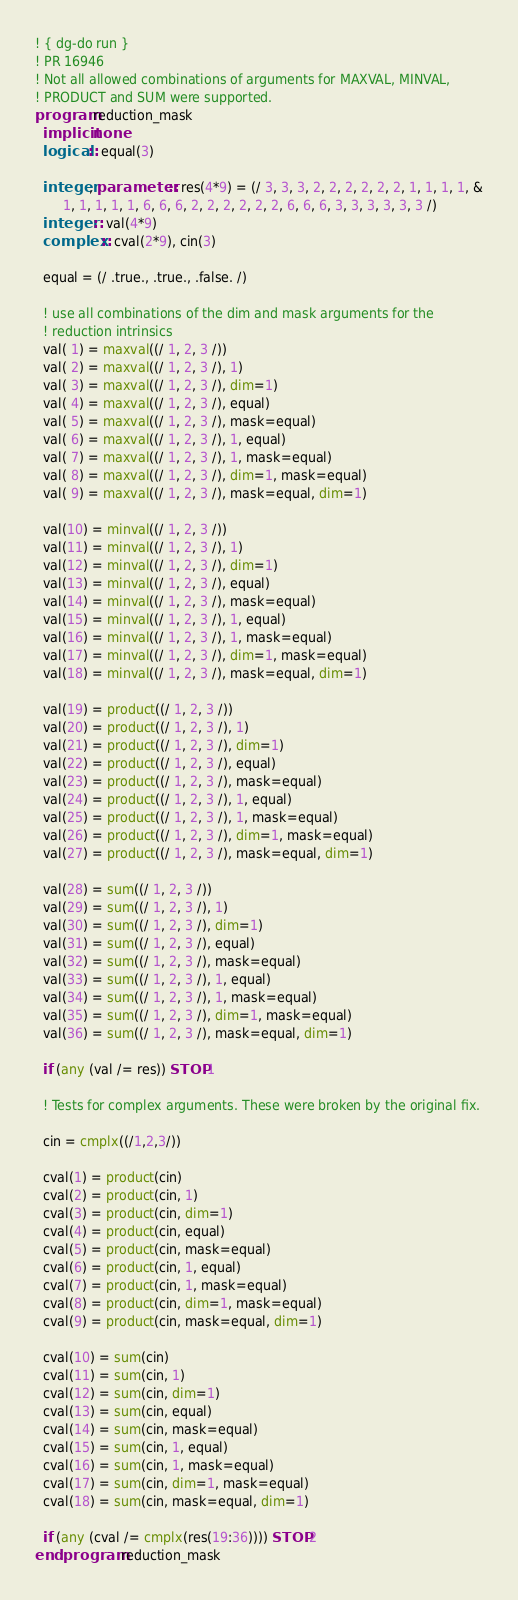<code> <loc_0><loc_0><loc_500><loc_500><_FORTRAN_>! { dg-do run }
! PR 16946
! Not all allowed combinations of arguments for MAXVAL, MINVAL,
! PRODUCT and SUM were supported.
program reduction_mask
  implicit none
  logical :: equal(3)
  
  integer, parameter :: res(4*9) = (/ 3, 3, 3, 2, 2, 2, 2, 2, 2, 1, 1, 1, 1, &
       1, 1, 1, 1, 1, 6, 6, 6, 2, 2, 2, 2, 2, 2, 6, 6, 6, 3, 3, 3, 3, 3, 3 /)
  integer :: val(4*9)
  complex :: cval(2*9), cin(3)
  
  equal = (/ .true., .true., .false. /)
  
  ! use all combinations of the dim and mask arguments for the
  ! reduction intrinsics
  val( 1) = maxval((/ 1, 2, 3 /))
  val( 2) = maxval((/ 1, 2, 3 /), 1)
  val( 3) = maxval((/ 1, 2, 3 /), dim=1)
  val( 4) = maxval((/ 1, 2, 3 /), equal)
  val( 5) = maxval((/ 1, 2, 3 /), mask=equal)
  val( 6) = maxval((/ 1, 2, 3 /), 1, equal)
  val( 7) = maxval((/ 1, 2, 3 /), 1, mask=equal)
  val( 8) = maxval((/ 1, 2, 3 /), dim=1, mask=equal)
  val( 9) = maxval((/ 1, 2, 3 /), mask=equal, dim=1)
       
  val(10) = minval((/ 1, 2, 3 /))
  val(11) = minval((/ 1, 2, 3 /), 1)
  val(12) = minval((/ 1, 2, 3 /), dim=1)
  val(13) = minval((/ 1, 2, 3 /), equal)
  val(14) = minval((/ 1, 2, 3 /), mask=equal)
  val(15) = minval((/ 1, 2, 3 /), 1, equal)
  val(16) = minval((/ 1, 2, 3 /), 1, mask=equal)
  val(17) = minval((/ 1, 2, 3 /), dim=1, mask=equal)
  val(18) = minval((/ 1, 2, 3 /), mask=equal, dim=1)
       
  val(19) = product((/ 1, 2, 3 /))
  val(20) = product((/ 1, 2, 3 /), 1)
  val(21) = product((/ 1, 2, 3 /), dim=1)
  val(22) = product((/ 1, 2, 3 /), equal)
  val(23) = product((/ 1, 2, 3 /), mask=equal)
  val(24) = product((/ 1, 2, 3 /), 1, equal)
  val(25) = product((/ 1, 2, 3 /), 1, mask=equal)
  val(26) = product((/ 1, 2, 3 /), dim=1, mask=equal)
  val(27) = product((/ 1, 2, 3 /), mask=equal, dim=1)
       
  val(28) = sum((/ 1, 2, 3 /))
  val(29) = sum((/ 1, 2, 3 /), 1)
  val(30) = sum((/ 1, 2, 3 /), dim=1)
  val(31) = sum((/ 1, 2, 3 /), equal)
  val(32) = sum((/ 1, 2, 3 /), mask=equal)
  val(33) = sum((/ 1, 2, 3 /), 1, equal)
  val(34) = sum((/ 1, 2, 3 /), 1, mask=equal)
  val(35) = sum((/ 1, 2, 3 /), dim=1, mask=equal)
  val(36) = sum((/ 1, 2, 3 /), mask=equal, dim=1)
  
  if (any (val /= res)) STOP 1

  ! Tests for complex arguments. These were broken by the original fix.

  cin = cmplx((/1,2,3/))

  cval(1) = product(cin)
  cval(2) = product(cin, 1)
  cval(3) = product(cin, dim=1)
  cval(4) = product(cin, equal)
  cval(5) = product(cin, mask=equal)
  cval(6) = product(cin, 1, equal)
  cval(7) = product(cin, 1, mask=equal)
  cval(8) = product(cin, dim=1, mask=equal)
  cval(9) = product(cin, mask=equal, dim=1)
       
  cval(10) = sum(cin)
  cval(11) = sum(cin, 1)
  cval(12) = sum(cin, dim=1)
  cval(13) = sum(cin, equal)
  cval(14) = sum(cin, mask=equal)
  cval(15) = sum(cin, 1, equal)
  cval(16) = sum(cin, 1, mask=equal)
  cval(17) = sum(cin, dim=1, mask=equal)
  cval(18) = sum(cin, mask=equal, dim=1)

  if (any (cval /= cmplx(res(19:36)))) STOP 2
end program reduction_mask
</code> 